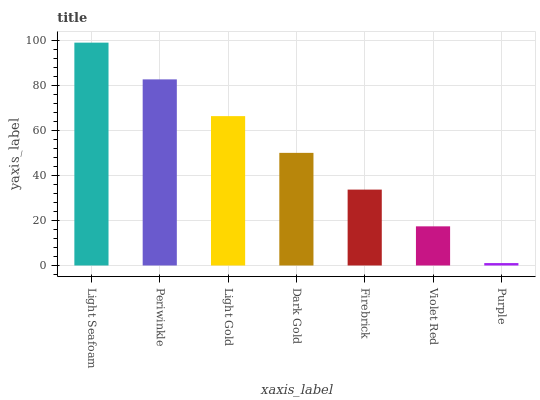Is Purple the minimum?
Answer yes or no. Yes. Is Light Seafoam the maximum?
Answer yes or no. Yes. Is Periwinkle the minimum?
Answer yes or no. No. Is Periwinkle the maximum?
Answer yes or no. No. Is Light Seafoam greater than Periwinkle?
Answer yes or no. Yes. Is Periwinkle less than Light Seafoam?
Answer yes or no. Yes. Is Periwinkle greater than Light Seafoam?
Answer yes or no. No. Is Light Seafoam less than Periwinkle?
Answer yes or no. No. Is Dark Gold the high median?
Answer yes or no. Yes. Is Dark Gold the low median?
Answer yes or no. Yes. Is Purple the high median?
Answer yes or no. No. Is Purple the low median?
Answer yes or no. No. 